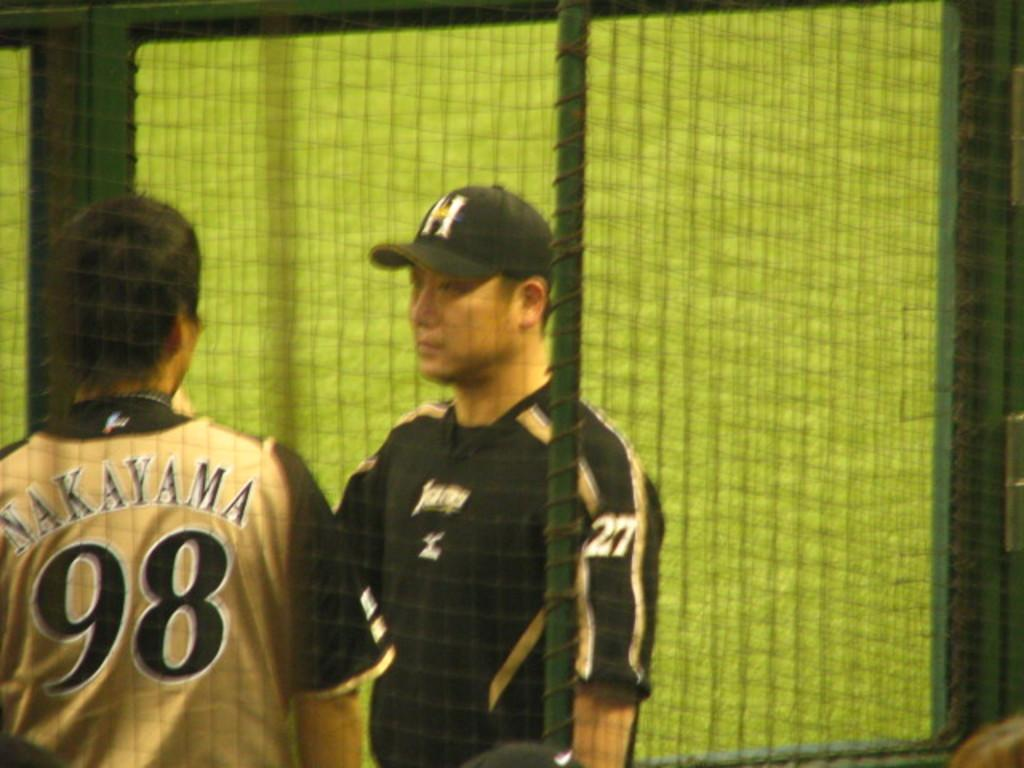<image>
Give a short and clear explanation of the subsequent image. Opposing players number 98 and 27 are having a conversation. 